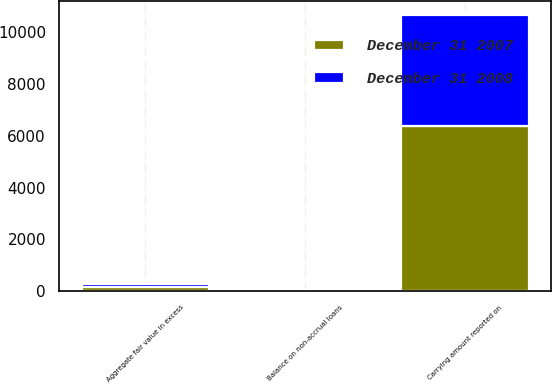<chart> <loc_0><loc_0><loc_500><loc_500><stacked_bar_chart><ecel><fcel>Carrying amount reported on<fcel>Aggregate fair value in excess<fcel>Balance on non-accrual loans<nl><fcel>December 31 2008<fcel>4273<fcel>138<fcel>9<nl><fcel>December 31 2007<fcel>6392<fcel>136<fcel>17<nl></chart> 